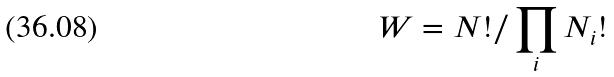Convert formula to latex. <formula><loc_0><loc_0><loc_500><loc_500>W = N ! / \prod _ { i } N _ { i } !</formula> 